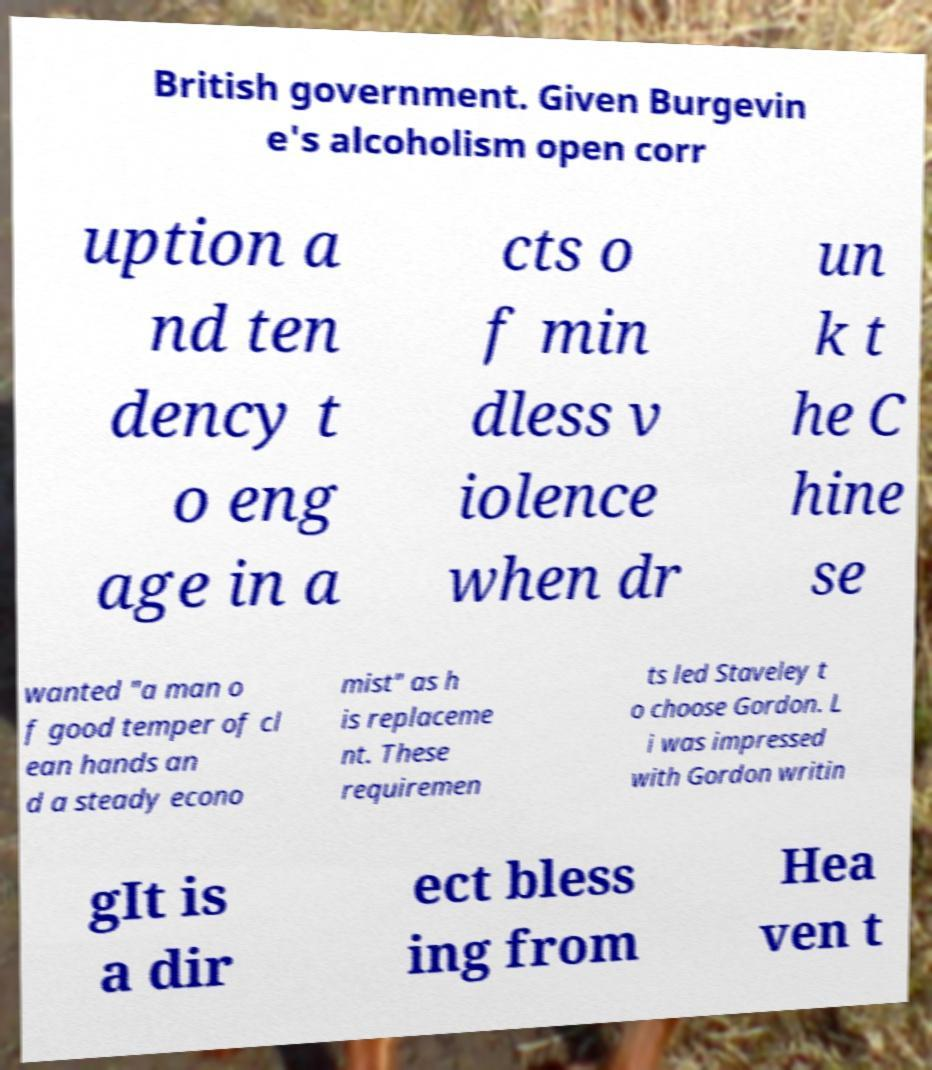Can you accurately transcribe the text from the provided image for me? British government. Given Burgevin e's alcoholism open corr uption a nd ten dency t o eng age in a cts o f min dless v iolence when dr un k t he C hine se wanted "a man o f good temper of cl ean hands an d a steady econo mist" as h is replaceme nt. These requiremen ts led Staveley t o choose Gordon. L i was impressed with Gordon writin gIt is a dir ect bless ing from Hea ven t 